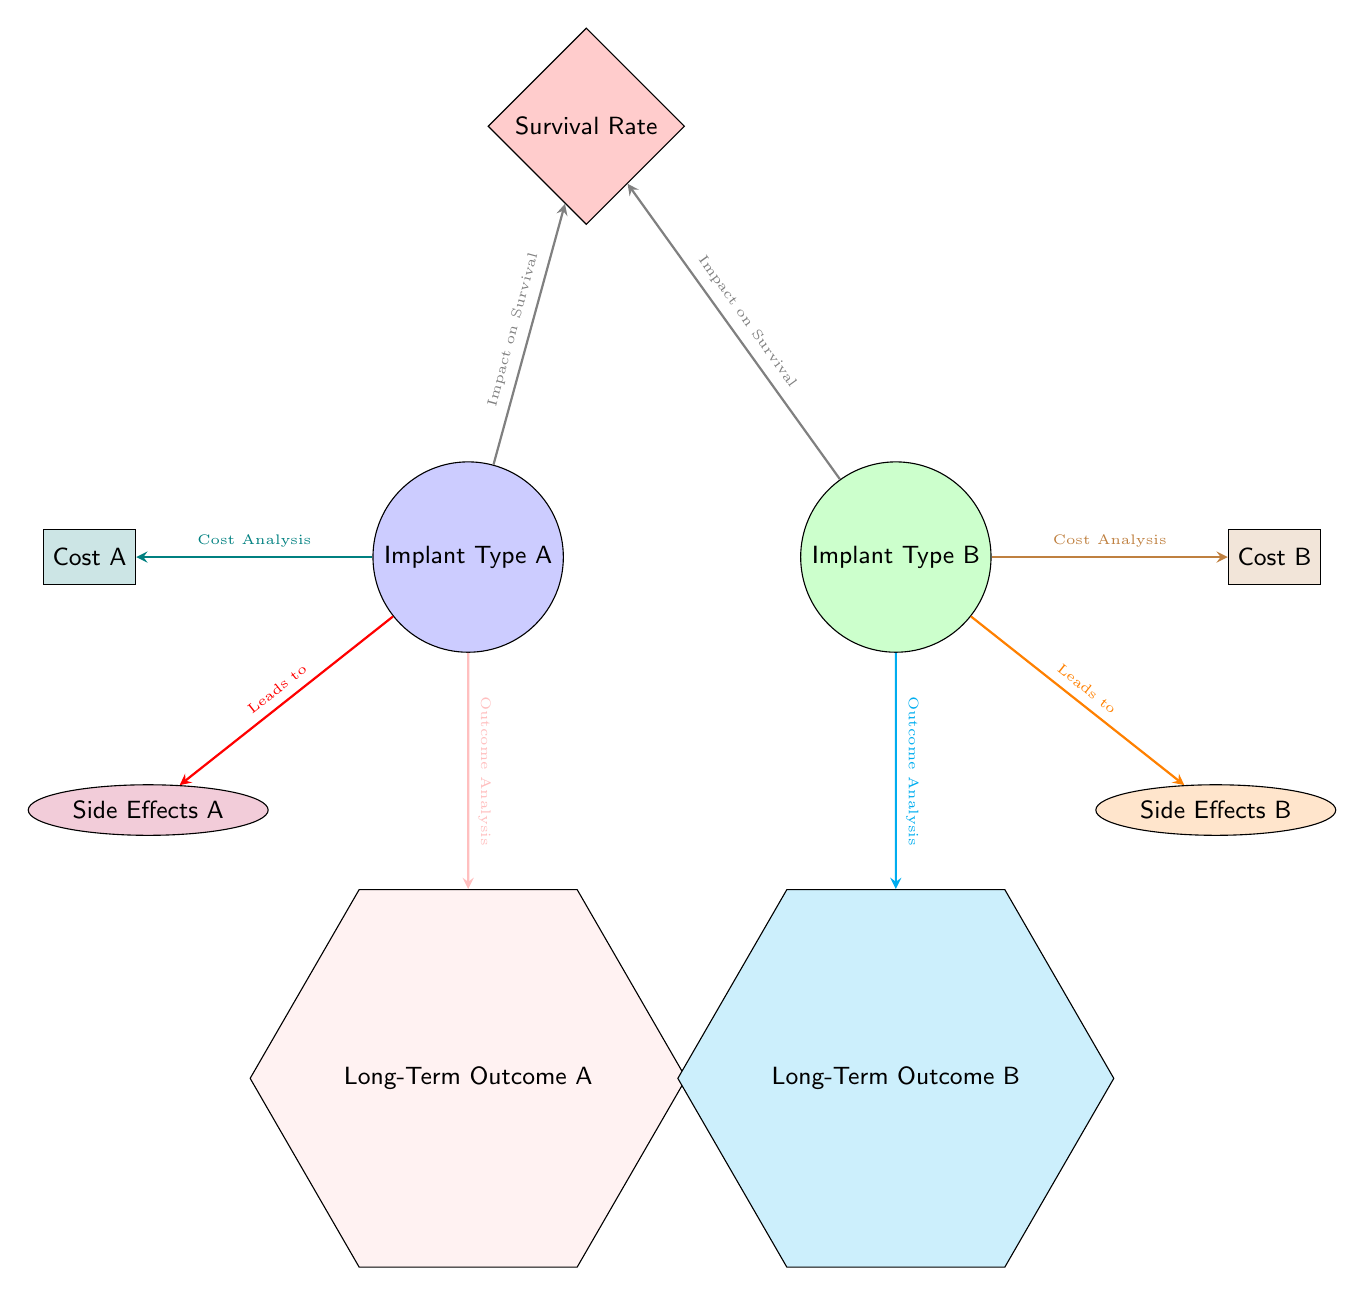What are the two types of implants depicted in the diagram? The diagram shows "Implant Type A" and "Implant Type B" as identified by the circular nodes at the top of the diagram.
Answer: Implant Type A, Implant Type B What color represents the Survival Rate in the diagram? The Survival Rate node is represented by a red diamond node, which is indicated in the diagram configuration.
Answer: Red Which implant type leads to Side Effects A? The edge from "Implant Type A" indicates that it directly leads to "Side Effects A," as shown by the red arrow connecting the two nodes.
Answer: Implant Type A How many total cost analyses are represented in the diagram? There are two cost analyses in the diagram, one for each implant type, indicated by the edges connecting "Cost A" and "Cost B" to their respective implants.
Answer: 2 What is the result of the outcome analysis for Implant Type B? The outcome analysis for "Implant Type B" is displayed as "Long-Term Outcome B," which follows the edge leading to that specific node in the diagram.
Answer: Long-Term Outcome B Which implant type has the lowest cost analysis shown in the diagram? The diagram specifies "Cost A" and "Cost B," but does not provide specific values; however, the node layout suggests a comparison. A deeper analysis of numerical data would be required to answer definitively. Given the absence of direct values, we cannot conclude which is lower from the diagram alone.
Answer: Not determinable What is the relationship between implants and survival rate? The diagram indicates that both "Implant Type A" and "Implant Type B" have edges leading to "Survival Rate," suggesting they both impact survival. The arrow indicates a directional influence from the implants to the survival rate.
Answer: Impact on Survival Which type of side effects are associated with Implant Type B? "Side Effects B" is specifically connected to "Implant Type B" by a directed edge, indicating that this implant type leads to the specified side effects.
Answer: Side Effects B Which shape represents long-term outcomes in the biomedical diagram? The long-term outcomes are represented by hexagon shapes, as outlined in the diagram for both types of implants in the respective hexagon nodes.
Answer: Hexagon 